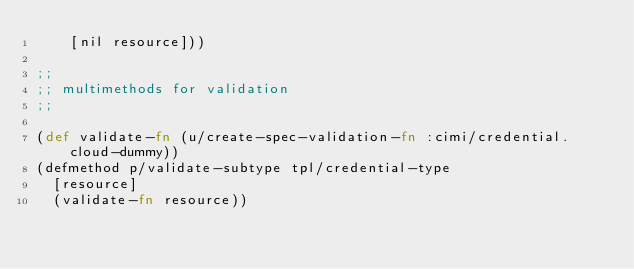Convert code to text. <code><loc_0><loc_0><loc_500><loc_500><_Clojure_>    [nil resource]))

;;
;; multimethods for validation
;;

(def validate-fn (u/create-spec-validation-fn :cimi/credential.cloud-dummy))
(defmethod p/validate-subtype tpl/credential-type
  [resource]
  (validate-fn resource))
</code> 